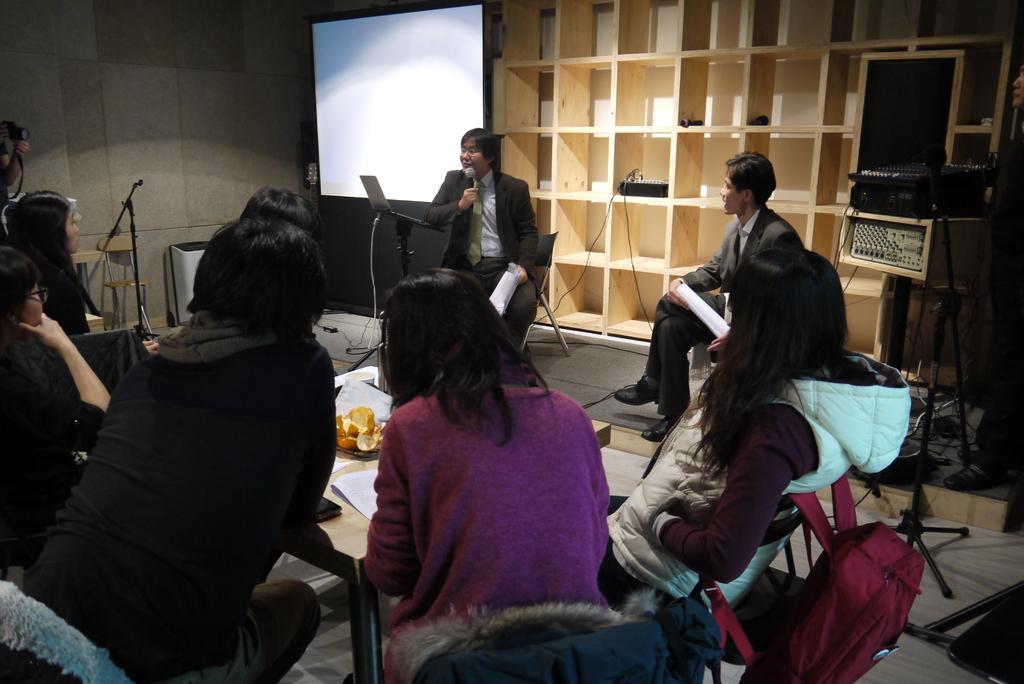How would you summarize this image in a sentence or two? In this image I can see a group of people sitting. I can see some objects on the table. In the background, I can see the shelf. 